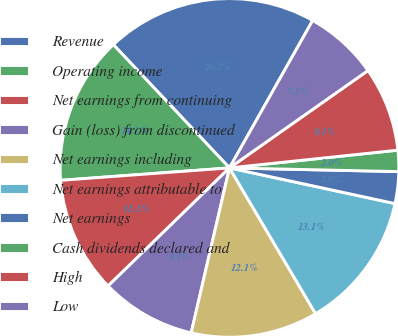Convert chart to OTSL. <chart><loc_0><loc_0><loc_500><loc_500><pie_chart><fcel>Revenue<fcel>Operating income<fcel>Net earnings from continuing<fcel>Gain (loss) from discontinued<fcel>Net earnings including<fcel>Net earnings attributable to<fcel>Net earnings<fcel>Cash dividends declared and<fcel>High<fcel>Low<nl><fcel>20.2%<fcel>14.14%<fcel>11.11%<fcel>9.09%<fcel>12.12%<fcel>13.13%<fcel>3.03%<fcel>2.02%<fcel>8.08%<fcel>7.07%<nl></chart> 